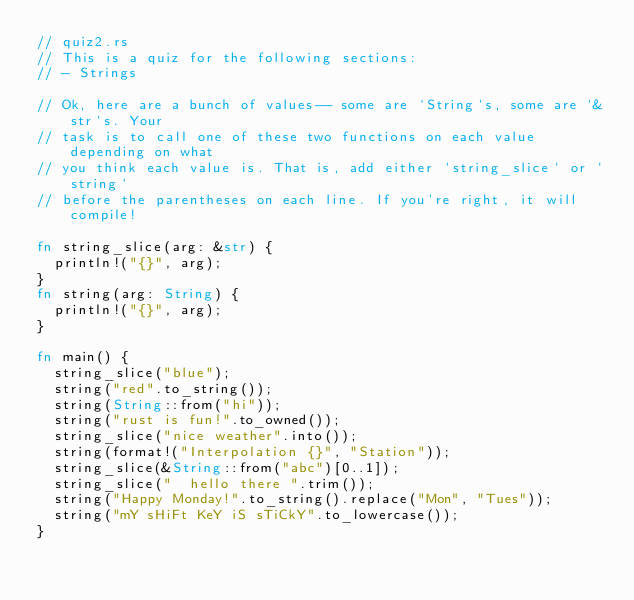<code> <loc_0><loc_0><loc_500><loc_500><_Rust_>// quiz2.rs
// This is a quiz for the following sections:
// - Strings

// Ok, here are a bunch of values-- some are `String`s, some are `&str`s. Your
// task is to call one of these two functions on each value depending on what
// you think each value is. That is, add either `string_slice` or `string`
// before the parentheses on each line. If you're right, it will compile!

fn string_slice(arg: &str) {
  println!("{}", arg);
}
fn string(arg: String) {
  println!("{}", arg);
}

fn main() {
  string_slice("blue");
  string("red".to_string());
  string(String::from("hi"));
  string("rust is fun!".to_owned());
  string_slice("nice weather".into());
  string(format!("Interpolation {}", "Station"));
  string_slice(&String::from("abc")[0..1]);
  string_slice("  hello there ".trim());
  string("Happy Monday!".to_string().replace("Mon", "Tues"));
  string("mY sHiFt KeY iS sTiCkY".to_lowercase());
}
</code> 